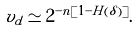Convert formula to latex. <formula><loc_0><loc_0><loc_500><loc_500>v _ { d } \simeq 2 ^ { - n [ 1 - H ( \delta ) ] } .</formula> 